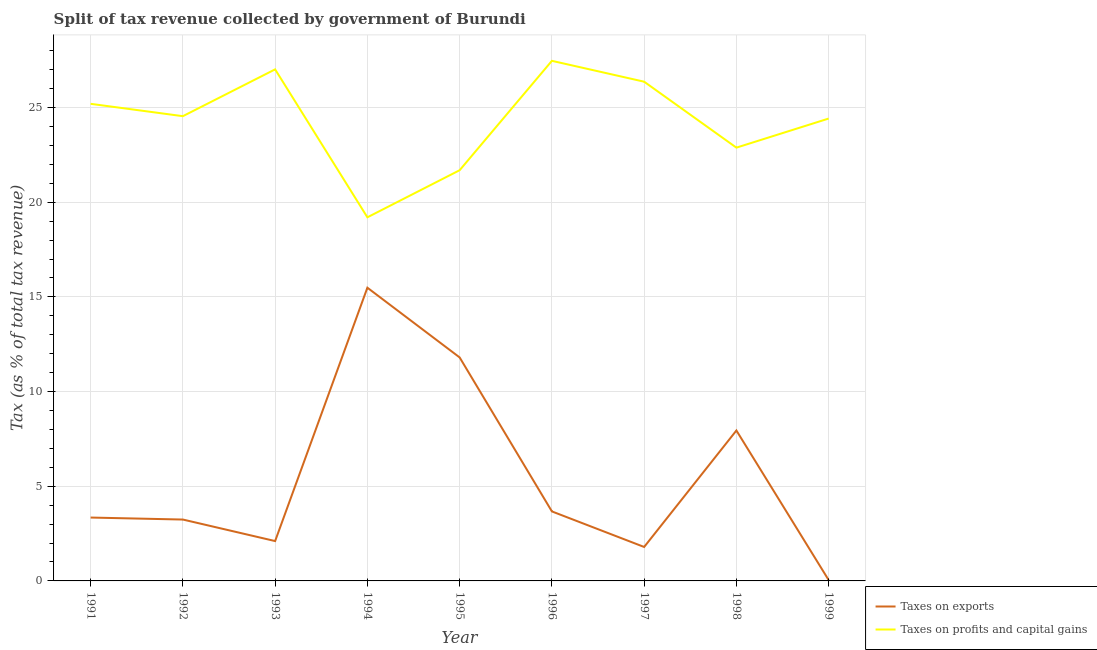How many different coloured lines are there?
Keep it short and to the point. 2. Does the line corresponding to percentage of revenue obtained from taxes on profits and capital gains intersect with the line corresponding to percentage of revenue obtained from taxes on exports?
Offer a terse response. No. Is the number of lines equal to the number of legend labels?
Your response must be concise. Yes. What is the percentage of revenue obtained from taxes on profits and capital gains in 1999?
Your response must be concise. 24.42. Across all years, what is the maximum percentage of revenue obtained from taxes on exports?
Make the answer very short. 15.49. Across all years, what is the minimum percentage of revenue obtained from taxes on profits and capital gains?
Ensure brevity in your answer.  19.2. What is the total percentage of revenue obtained from taxes on profits and capital gains in the graph?
Your answer should be very brief. 218.79. What is the difference between the percentage of revenue obtained from taxes on exports in 1992 and that in 1997?
Offer a very short reply. 1.45. What is the difference between the percentage of revenue obtained from taxes on profits and capital gains in 1996 and the percentage of revenue obtained from taxes on exports in 1991?
Your answer should be compact. 24.12. What is the average percentage of revenue obtained from taxes on exports per year?
Offer a very short reply. 5.49. In the year 1991, what is the difference between the percentage of revenue obtained from taxes on exports and percentage of revenue obtained from taxes on profits and capital gains?
Your answer should be compact. -21.85. What is the ratio of the percentage of revenue obtained from taxes on exports in 1993 to that in 1995?
Give a very brief answer. 0.18. Is the percentage of revenue obtained from taxes on exports in 1992 less than that in 1993?
Your response must be concise. No. Is the difference between the percentage of revenue obtained from taxes on profits and capital gains in 1996 and 1999 greater than the difference between the percentage of revenue obtained from taxes on exports in 1996 and 1999?
Your answer should be very brief. No. What is the difference between the highest and the second highest percentage of revenue obtained from taxes on profits and capital gains?
Your answer should be compact. 0.45. What is the difference between the highest and the lowest percentage of revenue obtained from taxes on profits and capital gains?
Provide a succinct answer. 8.26. Does the percentage of revenue obtained from taxes on profits and capital gains monotonically increase over the years?
Your response must be concise. No. Is the percentage of revenue obtained from taxes on profits and capital gains strictly greater than the percentage of revenue obtained from taxes on exports over the years?
Provide a succinct answer. Yes. Is the percentage of revenue obtained from taxes on profits and capital gains strictly less than the percentage of revenue obtained from taxes on exports over the years?
Keep it short and to the point. No. How many years are there in the graph?
Offer a terse response. 9. Does the graph contain any zero values?
Your answer should be compact. No. Does the graph contain grids?
Your response must be concise. Yes. How are the legend labels stacked?
Make the answer very short. Vertical. What is the title of the graph?
Provide a short and direct response. Split of tax revenue collected by government of Burundi. What is the label or title of the X-axis?
Provide a succinct answer. Year. What is the label or title of the Y-axis?
Offer a terse response. Tax (as % of total tax revenue). What is the Tax (as % of total tax revenue) in Taxes on exports in 1991?
Your response must be concise. 3.35. What is the Tax (as % of total tax revenue) in Taxes on profits and capital gains in 1991?
Offer a very short reply. 25.2. What is the Tax (as % of total tax revenue) of Taxes on exports in 1992?
Make the answer very short. 3.24. What is the Tax (as % of total tax revenue) of Taxes on profits and capital gains in 1992?
Give a very brief answer. 24.54. What is the Tax (as % of total tax revenue) of Taxes on exports in 1993?
Offer a terse response. 2.1. What is the Tax (as % of total tax revenue) of Taxes on profits and capital gains in 1993?
Offer a terse response. 27.02. What is the Tax (as % of total tax revenue) of Taxes on exports in 1994?
Your response must be concise. 15.49. What is the Tax (as % of total tax revenue) of Taxes on profits and capital gains in 1994?
Your answer should be compact. 19.2. What is the Tax (as % of total tax revenue) in Taxes on exports in 1995?
Provide a succinct answer. 11.8. What is the Tax (as % of total tax revenue) in Taxes on profits and capital gains in 1995?
Offer a terse response. 21.69. What is the Tax (as % of total tax revenue) of Taxes on exports in 1996?
Ensure brevity in your answer.  3.67. What is the Tax (as % of total tax revenue) in Taxes on profits and capital gains in 1996?
Ensure brevity in your answer.  27.47. What is the Tax (as % of total tax revenue) of Taxes on exports in 1997?
Provide a succinct answer. 1.79. What is the Tax (as % of total tax revenue) in Taxes on profits and capital gains in 1997?
Your answer should be compact. 26.37. What is the Tax (as % of total tax revenue) in Taxes on exports in 1998?
Your answer should be compact. 7.94. What is the Tax (as % of total tax revenue) of Taxes on profits and capital gains in 1998?
Give a very brief answer. 22.88. What is the Tax (as % of total tax revenue) in Taxes on exports in 1999?
Provide a short and direct response. 0.05. What is the Tax (as % of total tax revenue) of Taxes on profits and capital gains in 1999?
Offer a very short reply. 24.42. Across all years, what is the maximum Tax (as % of total tax revenue) of Taxes on exports?
Your answer should be compact. 15.49. Across all years, what is the maximum Tax (as % of total tax revenue) of Taxes on profits and capital gains?
Offer a very short reply. 27.47. Across all years, what is the minimum Tax (as % of total tax revenue) of Taxes on exports?
Make the answer very short. 0.05. Across all years, what is the minimum Tax (as % of total tax revenue) of Taxes on profits and capital gains?
Keep it short and to the point. 19.2. What is the total Tax (as % of total tax revenue) in Taxes on exports in the graph?
Give a very brief answer. 49.44. What is the total Tax (as % of total tax revenue) of Taxes on profits and capital gains in the graph?
Your answer should be very brief. 218.79. What is the difference between the Tax (as % of total tax revenue) of Taxes on exports in 1991 and that in 1992?
Give a very brief answer. 0.11. What is the difference between the Tax (as % of total tax revenue) in Taxes on profits and capital gains in 1991 and that in 1992?
Your response must be concise. 0.65. What is the difference between the Tax (as % of total tax revenue) of Taxes on exports in 1991 and that in 1993?
Offer a terse response. 1.24. What is the difference between the Tax (as % of total tax revenue) in Taxes on profits and capital gains in 1991 and that in 1993?
Keep it short and to the point. -1.82. What is the difference between the Tax (as % of total tax revenue) of Taxes on exports in 1991 and that in 1994?
Offer a terse response. -12.14. What is the difference between the Tax (as % of total tax revenue) in Taxes on profits and capital gains in 1991 and that in 1994?
Give a very brief answer. 5.99. What is the difference between the Tax (as % of total tax revenue) in Taxes on exports in 1991 and that in 1995?
Your answer should be compact. -8.46. What is the difference between the Tax (as % of total tax revenue) of Taxes on profits and capital gains in 1991 and that in 1995?
Your response must be concise. 3.51. What is the difference between the Tax (as % of total tax revenue) of Taxes on exports in 1991 and that in 1996?
Provide a short and direct response. -0.32. What is the difference between the Tax (as % of total tax revenue) of Taxes on profits and capital gains in 1991 and that in 1996?
Keep it short and to the point. -2.27. What is the difference between the Tax (as % of total tax revenue) of Taxes on exports in 1991 and that in 1997?
Offer a terse response. 1.55. What is the difference between the Tax (as % of total tax revenue) in Taxes on profits and capital gains in 1991 and that in 1997?
Provide a short and direct response. -1.17. What is the difference between the Tax (as % of total tax revenue) in Taxes on exports in 1991 and that in 1998?
Give a very brief answer. -4.6. What is the difference between the Tax (as % of total tax revenue) in Taxes on profits and capital gains in 1991 and that in 1998?
Offer a very short reply. 2.31. What is the difference between the Tax (as % of total tax revenue) in Taxes on exports in 1991 and that in 1999?
Ensure brevity in your answer.  3.3. What is the difference between the Tax (as % of total tax revenue) in Taxes on profits and capital gains in 1991 and that in 1999?
Offer a terse response. 0.78. What is the difference between the Tax (as % of total tax revenue) of Taxes on exports in 1992 and that in 1993?
Make the answer very short. 1.14. What is the difference between the Tax (as % of total tax revenue) of Taxes on profits and capital gains in 1992 and that in 1993?
Offer a very short reply. -2.47. What is the difference between the Tax (as % of total tax revenue) in Taxes on exports in 1992 and that in 1994?
Your response must be concise. -12.24. What is the difference between the Tax (as % of total tax revenue) in Taxes on profits and capital gains in 1992 and that in 1994?
Give a very brief answer. 5.34. What is the difference between the Tax (as % of total tax revenue) of Taxes on exports in 1992 and that in 1995?
Your answer should be compact. -8.56. What is the difference between the Tax (as % of total tax revenue) of Taxes on profits and capital gains in 1992 and that in 1995?
Keep it short and to the point. 2.85. What is the difference between the Tax (as % of total tax revenue) in Taxes on exports in 1992 and that in 1996?
Your response must be concise. -0.43. What is the difference between the Tax (as % of total tax revenue) in Taxes on profits and capital gains in 1992 and that in 1996?
Offer a terse response. -2.92. What is the difference between the Tax (as % of total tax revenue) in Taxes on exports in 1992 and that in 1997?
Your response must be concise. 1.45. What is the difference between the Tax (as % of total tax revenue) of Taxes on profits and capital gains in 1992 and that in 1997?
Offer a very short reply. -1.82. What is the difference between the Tax (as % of total tax revenue) in Taxes on exports in 1992 and that in 1998?
Provide a succinct answer. -4.7. What is the difference between the Tax (as % of total tax revenue) of Taxes on profits and capital gains in 1992 and that in 1998?
Ensure brevity in your answer.  1.66. What is the difference between the Tax (as % of total tax revenue) in Taxes on exports in 1992 and that in 1999?
Your response must be concise. 3.2. What is the difference between the Tax (as % of total tax revenue) of Taxes on profits and capital gains in 1992 and that in 1999?
Offer a very short reply. 0.12. What is the difference between the Tax (as % of total tax revenue) of Taxes on exports in 1993 and that in 1994?
Your answer should be compact. -13.38. What is the difference between the Tax (as % of total tax revenue) in Taxes on profits and capital gains in 1993 and that in 1994?
Provide a succinct answer. 7.81. What is the difference between the Tax (as % of total tax revenue) of Taxes on exports in 1993 and that in 1995?
Your response must be concise. -9.7. What is the difference between the Tax (as % of total tax revenue) of Taxes on profits and capital gains in 1993 and that in 1995?
Make the answer very short. 5.33. What is the difference between the Tax (as % of total tax revenue) in Taxes on exports in 1993 and that in 1996?
Provide a succinct answer. -1.57. What is the difference between the Tax (as % of total tax revenue) of Taxes on profits and capital gains in 1993 and that in 1996?
Keep it short and to the point. -0.45. What is the difference between the Tax (as % of total tax revenue) in Taxes on exports in 1993 and that in 1997?
Provide a succinct answer. 0.31. What is the difference between the Tax (as % of total tax revenue) in Taxes on profits and capital gains in 1993 and that in 1997?
Your response must be concise. 0.65. What is the difference between the Tax (as % of total tax revenue) of Taxes on exports in 1993 and that in 1998?
Keep it short and to the point. -5.84. What is the difference between the Tax (as % of total tax revenue) of Taxes on profits and capital gains in 1993 and that in 1998?
Your answer should be very brief. 4.13. What is the difference between the Tax (as % of total tax revenue) of Taxes on exports in 1993 and that in 1999?
Offer a terse response. 2.06. What is the difference between the Tax (as % of total tax revenue) of Taxes on profits and capital gains in 1993 and that in 1999?
Give a very brief answer. 2.6. What is the difference between the Tax (as % of total tax revenue) in Taxes on exports in 1994 and that in 1995?
Offer a terse response. 3.68. What is the difference between the Tax (as % of total tax revenue) in Taxes on profits and capital gains in 1994 and that in 1995?
Your response must be concise. -2.49. What is the difference between the Tax (as % of total tax revenue) of Taxes on exports in 1994 and that in 1996?
Offer a very short reply. 11.81. What is the difference between the Tax (as % of total tax revenue) of Taxes on profits and capital gains in 1994 and that in 1996?
Provide a short and direct response. -8.26. What is the difference between the Tax (as % of total tax revenue) of Taxes on exports in 1994 and that in 1997?
Your response must be concise. 13.69. What is the difference between the Tax (as % of total tax revenue) of Taxes on profits and capital gains in 1994 and that in 1997?
Provide a short and direct response. -7.16. What is the difference between the Tax (as % of total tax revenue) of Taxes on exports in 1994 and that in 1998?
Keep it short and to the point. 7.54. What is the difference between the Tax (as % of total tax revenue) of Taxes on profits and capital gains in 1994 and that in 1998?
Provide a short and direct response. -3.68. What is the difference between the Tax (as % of total tax revenue) of Taxes on exports in 1994 and that in 1999?
Your answer should be compact. 15.44. What is the difference between the Tax (as % of total tax revenue) in Taxes on profits and capital gains in 1994 and that in 1999?
Keep it short and to the point. -5.22. What is the difference between the Tax (as % of total tax revenue) of Taxes on exports in 1995 and that in 1996?
Make the answer very short. 8.13. What is the difference between the Tax (as % of total tax revenue) of Taxes on profits and capital gains in 1995 and that in 1996?
Ensure brevity in your answer.  -5.78. What is the difference between the Tax (as % of total tax revenue) of Taxes on exports in 1995 and that in 1997?
Give a very brief answer. 10.01. What is the difference between the Tax (as % of total tax revenue) in Taxes on profits and capital gains in 1995 and that in 1997?
Offer a very short reply. -4.68. What is the difference between the Tax (as % of total tax revenue) in Taxes on exports in 1995 and that in 1998?
Ensure brevity in your answer.  3.86. What is the difference between the Tax (as % of total tax revenue) of Taxes on profits and capital gains in 1995 and that in 1998?
Your answer should be very brief. -1.19. What is the difference between the Tax (as % of total tax revenue) in Taxes on exports in 1995 and that in 1999?
Your answer should be very brief. 11.76. What is the difference between the Tax (as % of total tax revenue) in Taxes on profits and capital gains in 1995 and that in 1999?
Offer a very short reply. -2.73. What is the difference between the Tax (as % of total tax revenue) in Taxes on exports in 1996 and that in 1997?
Your answer should be compact. 1.88. What is the difference between the Tax (as % of total tax revenue) in Taxes on profits and capital gains in 1996 and that in 1997?
Provide a short and direct response. 1.1. What is the difference between the Tax (as % of total tax revenue) in Taxes on exports in 1996 and that in 1998?
Offer a terse response. -4.27. What is the difference between the Tax (as % of total tax revenue) of Taxes on profits and capital gains in 1996 and that in 1998?
Ensure brevity in your answer.  4.58. What is the difference between the Tax (as % of total tax revenue) of Taxes on exports in 1996 and that in 1999?
Ensure brevity in your answer.  3.63. What is the difference between the Tax (as % of total tax revenue) of Taxes on profits and capital gains in 1996 and that in 1999?
Make the answer very short. 3.05. What is the difference between the Tax (as % of total tax revenue) in Taxes on exports in 1997 and that in 1998?
Offer a terse response. -6.15. What is the difference between the Tax (as % of total tax revenue) of Taxes on profits and capital gains in 1997 and that in 1998?
Your response must be concise. 3.48. What is the difference between the Tax (as % of total tax revenue) in Taxes on exports in 1997 and that in 1999?
Provide a succinct answer. 1.75. What is the difference between the Tax (as % of total tax revenue) of Taxes on profits and capital gains in 1997 and that in 1999?
Make the answer very short. 1.95. What is the difference between the Tax (as % of total tax revenue) in Taxes on exports in 1998 and that in 1999?
Your response must be concise. 7.9. What is the difference between the Tax (as % of total tax revenue) in Taxes on profits and capital gains in 1998 and that in 1999?
Your answer should be compact. -1.54. What is the difference between the Tax (as % of total tax revenue) in Taxes on exports in 1991 and the Tax (as % of total tax revenue) in Taxes on profits and capital gains in 1992?
Your answer should be compact. -21.2. What is the difference between the Tax (as % of total tax revenue) in Taxes on exports in 1991 and the Tax (as % of total tax revenue) in Taxes on profits and capital gains in 1993?
Offer a very short reply. -23.67. What is the difference between the Tax (as % of total tax revenue) in Taxes on exports in 1991 and the Tax (as % of total tax revenue) in Taxes on profits and capital gains in 1994?
Your response must be concise. -15.86. What is the difference between the Tax (as % of total tax revenue) in Taxes on exports in 1991 and the Tax (as % of total tax revenue) in Taxes on profits and capital gains in 1995?
Keep it short and to the point. -18.34. What is the difference between the Tax (as % of total tax revenue) in Taxes on exports in 1991 and the Tax (as % of total tax revenue) in Taxes on profits and capital gains in 1996?
Your response must be concise. -24.12. What is the difference between the Tax (as % of total tax revenue) of Taxes on exports in 1991 and the Tax (as % of total tax revenue) of Taxes on profits and capital gains in 1997?
Your answer should be very brief. -23.02. What is the difference between the Tax (as % of total tax revenue) in Taxes on exports in 1991 and the Tax (as % of total tax revenue) in Taxes on profits and capital gains in 1998?
Ensure brevity in your answer.  -19.54. What is the difference between the Tax (as % of total tax revenue) of Taxes on exports in 1991 and the Tax (as % of total tax revenue) of Taxes on profits and capital gains in 1999?
Your answer should be very brief. -21.07. What is the difference between the Tax (as % of total tax revenue) of Taxes on exports in 1992 and the Tax (as % of total tax revenue) of Taxes on profits and capital gains in 1993?
Your response must be concise. -23.78. What is the difference between the Tax (as % of total tax revenue) of Taxes on exports in 1992 and the Tax (as % of total tax revenue) of Taxes on profits and capital gains in 1994?
Ensure brevity in your answer.  -15.96. What is the difference between the Tax (as % of total tax revenue) in Taxes on exports in 1992 and the Tax (as % of total tax revenue) in Taxes on profits and capital gains in 1995?
Your answer should be very brief. -18.45. What is the difference between the Tax (as % of total tax revenue) of Taxes on exports in 1992 and the Tax (as % of total tax revenue) of Taxes on profits and capital gains in 1996?
Offer a terse response. -24.23. What is the difference between the Tax (as % of total tax revenue) of Taxes on exports in 1992 and the Tax (as % of total tax revenue) of Taxes on profits and capital gains in 1997?
Provide a succinct answer. -23.12. What is the difference between the Tax (as % of total tax revenue) of Taxes on exports in 1992 and the Tax (as % of total tax revenue) of Taxes on profits and capital gains in 1998?
Provide a short and direct response. -19.64. What is the difference between the Tax (as % of total tax revenue) of Taxes on exports in 1992 and the Tax (as % of total tax revenue) of Taxes on profits and capital gains in 1999?
Provide a succinct answer. -21.18. What is the difference between the Tax (as % of total tax revenue) of Taxes on exports in 1993 and the Tax (as % of total tax revenue) of Taxes on profits and capital gains in 1994?
Give a very brief answer. -17.1. What is the difference between the Tax (as % of total tax revenue) in Taxes on exports in 1993 and the Tax (as % of total tax revenue) in Taxes on profits and capital gains in 1995?
Provide a succinct answer. -19.59. What is the difference between the Tax (as % of total tax revenue) in Taxes on exports in 1993 and the Tax (as % of total tax revenue) in Taxes on profits and capital gains in 1996?
Your response must be concise. -25.36. What is the difference between the Tax (as % of total tax revenue) in Taxes on exports in 1993 and the Tax (as % of total tax revenue) in Taxes on profits and capital gains in 1997?
Give a very brief answer. -24.26. What is the difference between the Tax (as % of total tax revenue) in Taxes on exports in 1993 and the Tax (as % of total tax revenue) in Taxes on profits and capital gains in 1998?
Ensure brevity in your answer.  -20.78. What is the difference between the Tax (as % of total tax revenue) in Taxes on exports in 1993 and the Tax (as % of total tax revenue) in Taxes on profits and capital gains in 1999?
Your response must be concise. -22.32. What is the difference between the Tax (as % of total tax revenue) in Taxes on exports in 1994 and the Tax (as % of total tax revenue) in Taxes on profits and capital gains in 1995?
Give a very brief answer. -6.2. What is the difference between the Tax (as % of total tax revenue) of Taxes on exports in 1994 and the Tax (as % of total tax revenue) of Taxes on profits and capital gains in 1996?
Offer a very short reply. -11.98. What is the difference between the Tax (as % of total tax revenue) in Taxes on exports in 1994 and the Tax (as % of total tax revenue) in Taxes on profits and capital gains in 1997?
Make the answer very short. -10.88. What is the difference between the Tax (as % of total tax revenue) of Taxes on exports in 1994 and the Tax (as % of total tax revenue) of Taxes on profits and capital gains in 1998?
Your answer should be very brief. -7.4. What is the difference between the Tax (as % of total tax revenue) of Taxes on exports in 1994 and the Tax (as % of total tax revenue) of Taxes on profits and capital gains in 1999?
Provide a short and direct response. -8.93. What is the difference between the Tax (as % of total tax revenue) of Taxes on exports in 1995 and the Tax (as % of total tax revenue) of Taxes on profits and capital gains in 1996?
Make the answer very short. -15.66. What is the difference between the Tax (as % of total tax revenue) of Taxes on exports in 1995 and the Tax (as % of total tax revenue) of Taxes on profits and capital gains in 1997?
Your answer should be compact. -14.56. What is the difference between the Tax (as % of total tax revenue) of Taxes on exports in 1995 and the Tax (as % of total tax revenue) of Taxes on profits and capital gains in 1998?
Your response must be concise. -11.08. What is the difference between the Tax (as % of total tax revenue) of Taxes on exports in 1995 and the Tax (as % of total tax revenue) of Taxes on profits and capital gains in 1999?
Your answer should be compact. -12.62. What is the difference between the Tax (as % of total tax revenue) in Taxes on exports in 1996 and the Tax (as % of total tax revenue) in Taxes on profits and capital gains in 1997?
Make the answer very short. -22.69. What is the difference between the Tax (as % of total tax revenue) in Taxes on exports in 1996 and the Tax (as % of total tax revenue) in Taxes on profits and capital gains in 1998?
Keep it short and to the point. -19.21. What is the difference between the Tax (as % of total tax revenue) of Taxes on exports in 1996 and the Tax (as % of total tax revenue) of Taxes on profits and capital gains in 1999?
Provide a short and direct response. -20.75. What is the difference between the Tax (as % of total tax revenue) of Taxes on exports in 1997 and the Tax (as % of total tax revenue) of Taxes on profits and capital gains in 1998?
Your answer should be very brief. -21.09. What is the difference between the Tax (as % of total tax revenue) of Taxes on exports in 1997 and the Tax (as % of total tax revenue) of Taxes on profits and capital gains in 1999?
Give a very brief answer. -22.63. What is the difference between the Tax (as % of total tax revenue) of Taxes on exports in 1998 and the Tax (as % of total tax revenue) of Taxes on profits and capital gains in 1999?
Your answer should be very brief. -16.48. What is the average Tax (as % of total tax revenue) in Taxes on exports per year?
Your answer should be very brief. 5.49. What is the average Tax (as % of total tax revenue) of Taxes on profits and capital gains per year?
Your answer should be very brief. 24.31. In the year 1991, what is the difference between the Tax (as % of total tax revenue) of Taxes on exports and Tax (as % of total tax revenue) of Taxes on profits and capital gains?
Offer a very short reply. -21.85. In the year 1992, what is the difference between the Tax (as % of total tax revenue) in Taxes on exports and Tax (as % of total tax revenue) in Taxes on profits and capital gains?
Make the answer very short. -21.3. In the year 1993, what is the difference between the Tax (as % of total tax revenue) of Taxes on exports and Tax (as % of total tax revenue) of Taxes on profits and capital gains?
Provide a short and direct response. -24.91. In the year 1994, what is the difference between the Tax (as % of total tax revenue) in Taxes on exports and Tax (as % of total tax revenue) in Taxes on profits and capital gains?
Provide a succinct answer. -3.72. In the year 1995, what is the difference between the Tax (as % of total tax revenue) of Taxes on exports and Tax (as % of total tax revenue) of Taxes on profits and capital gains?
Provide a succinct answer. -9.89. In the year 1996, what is the difference between the Tax (as % of total tax revenue) in Taxes on exports and Tax (as % of total tax revenue) in Taxes on profits and capital gains?
Your answer should be compact. -23.8. In the year 1997, what is the difference between the Tax (as % of total tax revenue) in Taxes on exports and Tax (as % of total tax revenue) in Taxes on profits and capital gains?
Keep it short and to the point. -24.57. In the year 1998, what is the difference between the Tax (as % of total tax revenue) of Taxes on exports and Tax (as % of total tax revenue) of Taxes on profits and capital gains?
Ensure brevity in your answer.  -14.94. In the year 1999, what is the difference between the Tax (as % of total tax revenue) in Taxes on exports and Tax (as % of total tax revenue) in Taxes on profits and capital gains?
Make the answer very short. -24.37. What is the ratio of the Tax (as % of total tax revenue) in Taxes on exports in 1991 to that in 1992?
Your response must be concise. 1.03. What is the ratio of the Tax (as % of total tax revenue) in Taxes on profits and capital gains in 1991 to that in 1992?
Give a very brief answer. 1.03. What is the ratio of the Tax (as % of total tax revenue) of Taxes on exports in 1991 to that in 1993?
Ensure brevity in your answer.  1.59. What is the ratio of the Tax (as % of total tax revenue) in Taxes on profits and capital gains in 1991 to that in 1993?
Give a very brief answer. 0.93. What is the ratio of the Tax (as % of total tax revenue) of Taxes on exports in 1991 to that in 1994?
Give a very brief answer. 0.22. What is the ratio of the Tax (as % of total tax revenue) of Taxes on profits and capital gains in 1991 to that in 1994?
Keep it short and to the point. 1.31. What is the ratio of the Tax (as % of total tax revenue) in Taxes on exports in 1991 to that in 1995?
Make the answer very short. 0.28. What is the ratio of the Tax (as % of total tax revenue) of Taxes on profits and capital gains in 1991 to that in 1995?
Make the answer very short. 1.16. What is the ratio of the Tax (as % of total tax revenue) of Taxes on exports in 1991 to that in 1996?
Offer a very short reply. 0.91. What is the ratio of the Tax (as % of total tax revenue) of Taxes on profits and capital gains in 1991 to that in 1996?
Provide a succinct answer. 0.92. What is the ratio of the Tax (as % of total tax revenue) of Taxes on exports in 1991 to that in 1997?
Offer a very short reply. 1.87. What is the ratio of the Tax (as % of total tax revenue) in Taxes on profits and capital gains in 1991 to that in 1997?
Your answer should be compact. 0.96. What is the ratio of the Tax (as % of total tax revenue) of Taxes on exports in 1991 to that in 1998?
Your answer should be compact. 0.42. What is the ratio of the Tax (as % of total tax revenue) in Taxes on profits and capital gains in 1991 to that in 1998?
Provide a succinct answer. 1.1. What is the ratio of the Tax (as % of total tax revenue) in Taxes on exports in 1991 to that in 1999?
Your answer should be very brief. 72.98. What is the ratio of the Tax (as % of total tax revenue) of Taxes on profits and capital gains in 1991 to that in 1999?
Provide a succinct answer. 1.03. What is the ratio of the Tax (as % of total tax revenue) of Taxes on exports in 1992 to that in 1993?
Offer a very short reply. 1.54. What is the ratio of the Tax (as % of total tax revenue) in Taxes on profits and capital gains in 1992 to that in 1993?
Make the answer very short. 0.91. What is the ratio of the Tax (as % of total tax revenue) of Taxes on exports in 1992 to that in 1994?
Your answer should be very brief. 0.21. What is the ratio of the Tax (as % of total tax revenue) in Taxes on profits and capital gains in 1992 to that in 1994?
Offer a terse response. 1.28. What is the ratio of the Tax (as % of total tax revenue) in Taxes on exports in 1992 to that in 1995?
Make the answer very short. 0.27. What is the ratio of the Tax (as % of total tax revenue) of Taxes on profits and capital gains in 1992 to that in 1995?
Your answer should be compact. 1.13. What is the ratio of the Tax (as % of total tax revenue) of Taxes on exports in 1992 to that in 1996?
Provide a succinct answer. 0.88. What is the ratio of the Tax (as % of total tax revenue) of Taxes on profits and capital gains in 1992 to that in 1996?
Your answer should be very brief. 0.89. What is the ratio of the Tax (as % of total tax revenue) in Taxes on exports in 1992 to that in 1997?
Keep it short and to the point. 1.81. What is the ratio of the Tax (as % of total tax revenue) in Taxes on profits and capital gains in 1992 to that in 1997?
Provide a short and direct response. 0.93. What is the ratio of the Tax (as % of total tax revenue) in Taxes on exports in 1992 to that in 1998?
Your answer should be very brief. 0.41. What is the ratio of the Tax (as % of total tax revenue) in Taxes on profits and capital gains in 1992 to that in 1998?
Offer a very short reply. 1.07. What is the ratio of the Tax (as % of total tax revenue) of Taxes on exports in 1992 to that in 1999?
Make the answer very short. 70.68. What is the ratio of the Tax (as % of total tax revenue) of Taxes on profits and capital gains in 1992 to that in 1999?
Provide a short and direct response. 1.01. What is the ratio of the Tax (as % of total tax revenue) of Taxes on exports in 1993 to that in 1994?
Your answer should be compact. 0.14. What is the ratio of the Tax (as % of total tax revenue) of Taxes on profits and capital gains in 1993 to that in 1994?
Offer a very short reply. 1.41. What is the ratio of the Tax (as % of total tax revenue) in Taxes on exports in 1993 to that in 1995?
Provide a short and direct response. 0.18. What is the ratio of the Tax (as % of total tax revenue) in Taxes on profits and capital gains in 1993 to that in 1995?
Provide a short and direct response. 1.25. What is the ratio of the Tax (as % of total tax revenue) of Taxes on exports in 1993 to that in 1996?
Offer a very short reply. 0.57. What is the ratio of the Tax (as % of total tax revenue) in Taxes on profits and capital gains in 1993 to that in 1996?
Offer a terse response. 0.98. What is the ratio of the Tax (as % of total tax revenue) of Taxes on exports in 1993 to that in 1997?
Offer a very short reply. 1.17. What is the ratio of the Tax (as % of total tax revenue) in Taxes on profits and capital gains in 1993 to that in 1997?
Your response must be concise. 1.02. What is the ratio of the Tax (as % of total tax revenue) of Taxes on exports in 1993 to that in 1998?
Ensure brevity in your answer.  0.26. What is the ratio of the Tax (as % of total tax revenue) in Taxes on profits and capital gains in 1993 to that in 1998?
Make the answer very short. 1.18. What is the ratio of the Tax (as % of total tax revenue) in Taxes on exports in 1993 to that in 1999?
Give a very brief answer. 45.89. What is the ratio of the Tax (as % of total tax revenue) in Taxes on profits and capital gains in 1993 to that in 1999?
Provide a succinct answer. 1.11. What is the ratio of the Tax (as % of total tax revenue) of Taxes on exports in 1994 to that in 1995?
Keep it short and to the point. 1.31. What is the ratio of the Tax (as % of total tax revenue) in Taxes on profits and capital gains in 1994 to that in 1995?
Your answer should be very brief. 0.89. What is the ratio of the Tax (as % of total tax revenue) of Taxes on exports in 1994 to that in 1996?
Make the answer very short. 4.22. What is the ratio of the Tax (as % of total tax revenue) in Taxes on profits and capital gains in 1994 to that in 1996?
Offer a terse response. 0.7. What is the ratio of the Tax (as % of total tax revenue) of Taxes on exports in 1994 to that in 1997?
Offer a terse response. 8.64. What is the ratio of the Tax (as % of total tax revenue) of Taxes on profits and capital gains in 1994 to that in 1997?
Make the answer very short. 0.73. What is the ratio of the Tax (as % of total tax revenue) in Taxes on exports in 1994 to that in 1998?
Provide a short and direct response. 1.95. What is the ratio of the Tax (as % of total tax revenue) of Taxes on profits and capital gains in 1994 to that in 1998?
Your answer should be very brief. 0.84. What is the ratio of the Tax (as % of total tax revenue) in Taxes on exports in 1994 to that in 1999?
Your response must be concise. 337.65. What is the ratio of the Tax (as % of total tax revenue) in Taxes on profits and capital gains in 1994 to that in 1999?
Give a very brief answer. 0.79. What is the ratio of the Tax (as % of total tax revenue) of Taxes on exports in 1995 to that in 1996?
Your answer should be very brief. 3.22. What is the ratio of the Tax (as % of total tax revenue) in Taxes on profits and capital gains in 1995 to that in 1996?
Make the answer very short. 0.79. What is the ratio of the Tax (as % of total tax revenue) of Taxes on exports in 1995 to that in 1997?
Provide a succinct answer. 6.58. What is the ratio of the Tax (as % of total tax revenue) of Taxes on profits and capital gains in 1995 to that in 1997?
Your response must be concise. 0.82. What is the ratio of the Tax (as % of total tax revenue) in Taxes on exports in 1995 to that in 1998?
Make the answer very short. 1.49. What is the ratio of the Tax (as % of total tax revenue) in Taxes on profits and capital gains in 1995 to that in 1998?
Your answer should be very brief. 0.95. What is the ratio of the Tax (as % of total tax revenue) in Taxes on exports in 1995 to that in 1999?
Your response must be concise. 257.37. What is the ratio of the Tax (as % of total tax revenue) in Taxes on profits and capital gains in 1995 to that in 1999?
Your answer should be very brief. 0.89. What is the ratio of the Tax (as % of total tax revenue) of Taxes on exports in 1996 to that in 1997?
Offer a terse response. 2.05. What is the ratio of the Tax (as % of total tax revenue) of Taxes on profits and capital gains in 1996 to that in 1997?
Your response must be concise. 1.04. What is the ratio of the Tax (as % of total tax revenue) in Taxes on exports in 1996 to that in 1998?
Offer a terse response. 0.46. What is the ratio of the Tax (as % of total tax revenue) in Taxes on profits and capital gains in 1996 to that in 1998?
Offer a terse response. 1.2. What is the ratio of the Tax (as % of total tax revenue) in Taxes on exports in 1996 to that in 1999?
Provide a short and direct response. 80.04. What is the ratio of the Tax (as % of total tax revenue) of Taxes on profits and capital gains in 1996 to that in 1999?
Your response must be concise. 1.12. What is the ratio of the Tax (as % of total tax revenue) in Taxes on exports in 1997 to that in 1998?
Your answer should be very brief. 0.23. What is the ratio of the Tax (as % of total tax revenue) in Taxes on profits and capital gains in 1997 to that in 1998?
Your response must be concise. 1.15. What is the ratio of the Tax (as % of total tax revenue) of Taxes on exports in 1997 to that in 1999?
Keep it short and to the point. 39.1. What is the ratio of the Tax (as % of total tax revenue) of Taxes on profits and capital gains in 1997 to that in 1999?
Your answer should be compact. 1.08. What is the ratio of the Tax (as % of total tax revenue) of Taxes on exports in 1998 to that in 1999?
Make the answer very short. 173.23. What is the ratio of the Tax (as % of total tax revenue) in Taxes on profits and capital gains in 1998 to that in 1999?
Give a very brief answer. 0.94. What is the difference between the highest and the second highest Tax (as % of total tax revenue) in Taxes on exports?
Your response must be concise. 3.68. What is the difference between the highest and the second highest Tax (as % of total tax revenue) of Taxes on profits and capital gains?
Your response must be concise. 0.45. What is the difference between the highest and the lowest Tax (as % of total tax revenue) of Taxes on exports?
Your answer should be very brief. 15.44. What is the difference between the highest and the lowest Tax (as % of total tax revenue) in Taxes on profits and capital gains?
Provide a succinct answer. 8.26. 